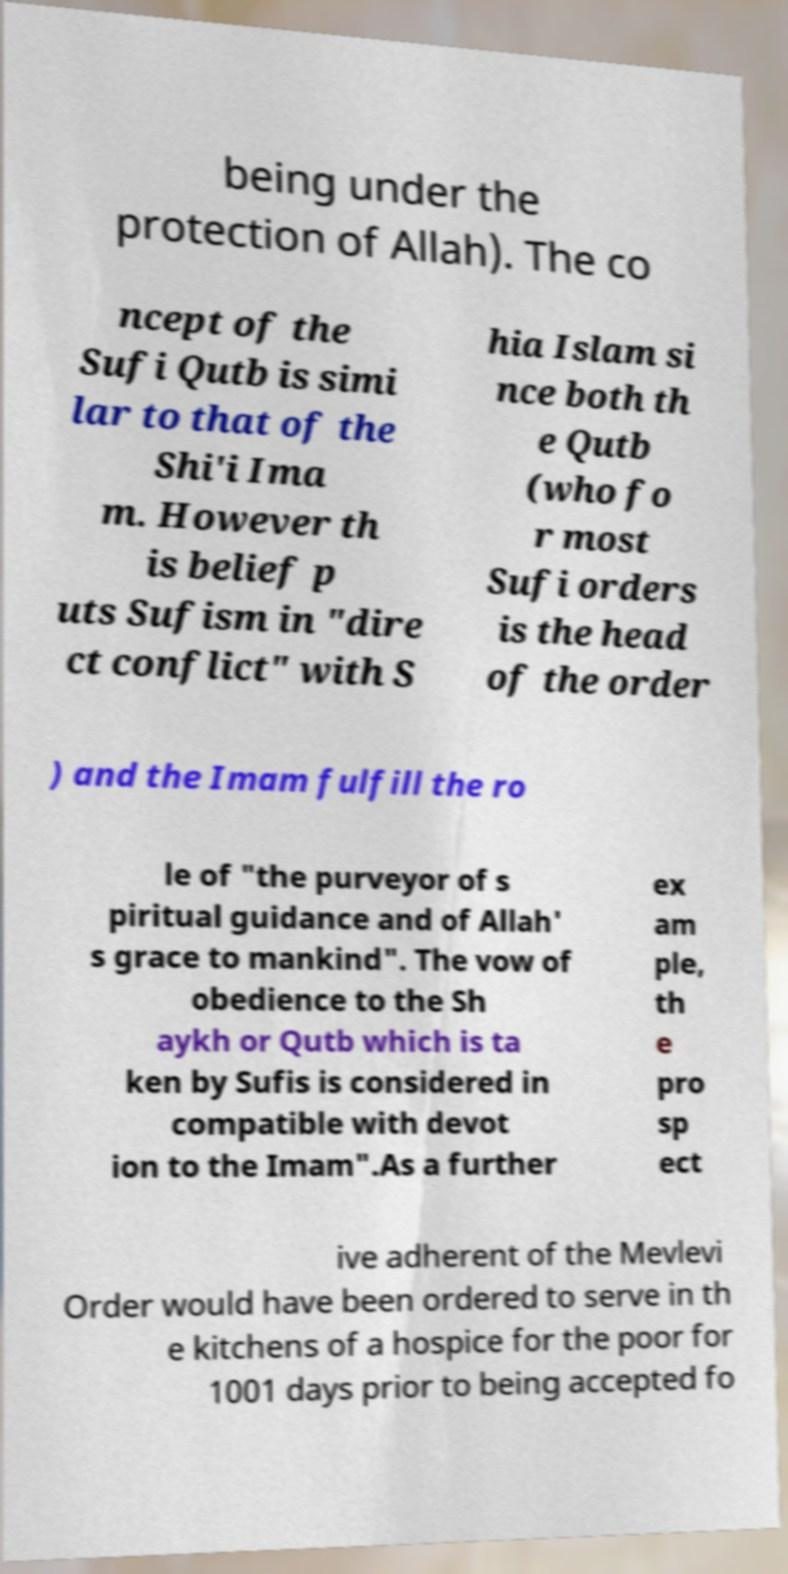I need the written content from this picture converted into text. Can you do that? being under the protection of Allah). The co ncept of the Sufi Qutb is simi lar to that of the Shi'i Ima m. However th is belief p uts Sufism in "dire ct conflict" with S hia Islam si nce both th e Qutb (who fo r most Sufi orders is the head of the order ) and the Imam fulfill the ro le of "the purveyor of s piritual guidance and of Allah' s grace to mankind". The vow of obedience to the Sh aykh or Qutb which is ta ken by Sufis is considered in compatible with devot ion to the Imam".As a further ex am ple, th e pro sp ect ive adherent of the Mevlevi Order would have been ordered to serve in th e kitchens of a hospice for the poor for 1001 days prior to being accepted fo 